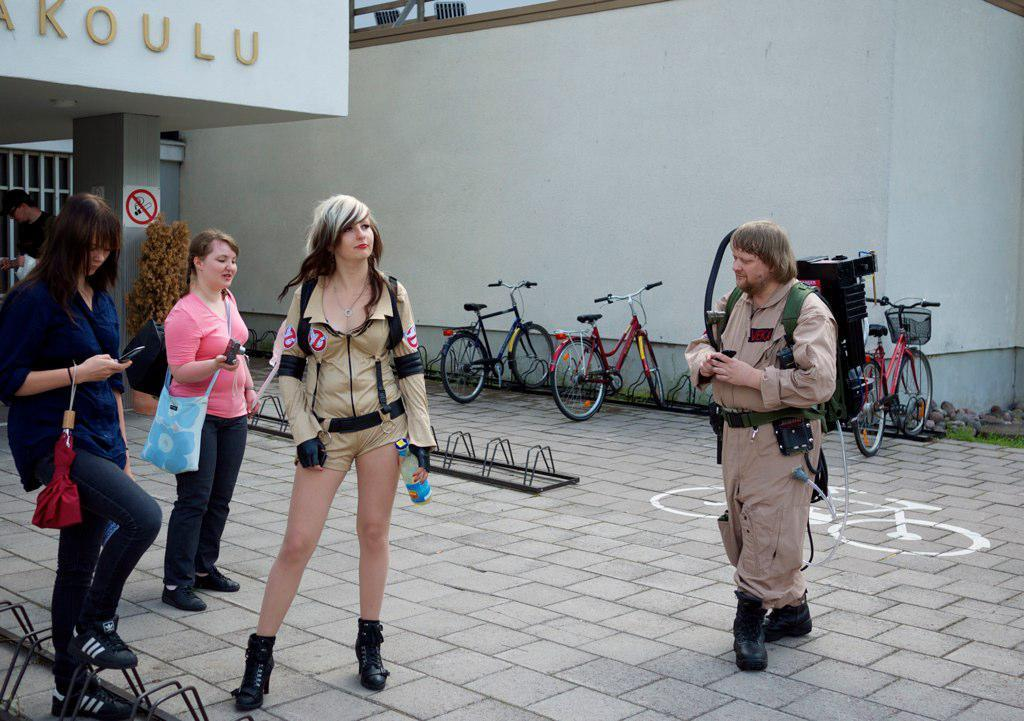What are the people in the image doing? The people in the image are standing and walking. What can be seen behind the people? There are bicycles behind the people. What structure is visible at the top of the image? There is a building at the top of the image. What type of sand can be seen on the ground in the image? There is no sand visible in the image; it features people standing and walking, bicycles, and a building. 